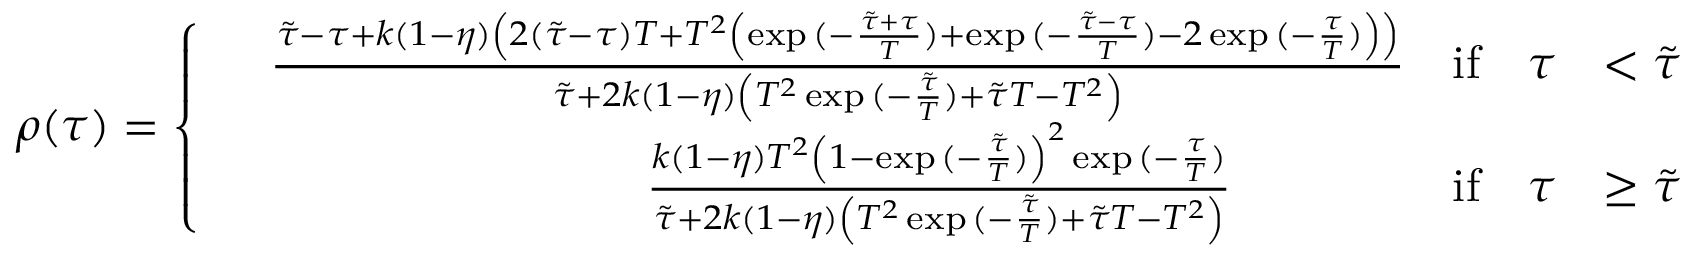Convert formula to latex. <formula><loc_0><loc_0><loc_500><loc_500>\rho ( \tau ) = \left \{ \begin{array} { r l r l } & { \frac { \tilde { \tau } - \tau + k ( 1 - \eta ) \left ( 2 ( \tilde { \tau } - \tau ) T + T ^ { 2 } \left ( \exp { ( - \frac { \tilde { \tau } + \tau } { T } ) } + \exp { ( - \frac { \tilde { \tau } - \tau } { T } ) } - 2 \exp { ( - \frac { \tau } { T } ) } \right ) \right ) } { \tilde { \tau } + 2 k ( 1 - \eta ) \left ( T ^ { 2 } \exp { ( - \frac { \tilde { \tau } } { T } ) } + \tilde { \tau } T - T ^ { 2 } \right ) } } & { i f \quad \tau } & { < \tilde { \tau } } \\ & { \quad \frac { k ( 1 - \eta ) T ^ { 2 } \left ( 1 - \exp { ( - \frac { \tilde { \tau } } { T } ) } \right ) ^ { 2 } \exp { ( - \frac { \tau } { T } ) } } { \tilde { \tau } + 2 k ( 1 - \eta ) \left ( T ^ { 2 } \exp { ( - \frac { \tilde { \tau } } { T } ) } + \tilde { \tau } T - T ^ { 2 } \right ) } } & { i f \quad \tau } & { \geq \tilde { \tau } } \end{array}</formula> 